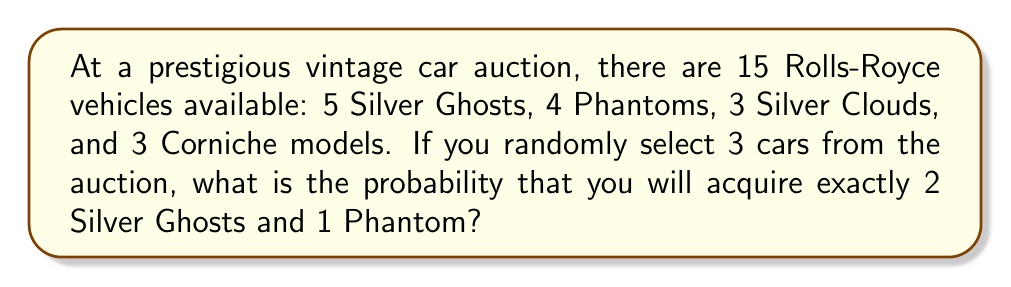Solve this math problem. To solve this problem, we'll use the concept of combinations and the multiplication principle of probability.

Step 1: Calculate the total number of ways to select 3 cars out of 15.
Total combinations = $\binom{15}{3} = \frac{15!}{3!(15-3)!} = 455$

Step 2: Calculate the number of ways to select 2 Silver Ghosts out of 5.
Silver Ghost combinations = $\binom{5}{2} = \frac{5!}{2!(5-2)!} = 10$

Step 3: Calculate the number of ways to select 1 Phantom out of 4.
Phantom combinations = $\binom{4}{1} = \frac{4!}{1!(4-1)!} = 4$

Step 4: Apply the multiplication principle to find the number of favorable outcomes.
Favorable outcomes = $10 \times 4 = 40$

Step 5: Calculate the probability by dividing favorable outcomes by total outcomes.
Probability = $\frac{40}{455} = \frac{8}{91} \approx 0.0879$

Therefore, the probability of acquiring exactly 2 Silver Ghosts and 1 Phantom when randomly selecting 3 cars from the auction is $\frac{8}{91}$ or approximately 8.79%.
Answer: $\frac{8}{91}$ 